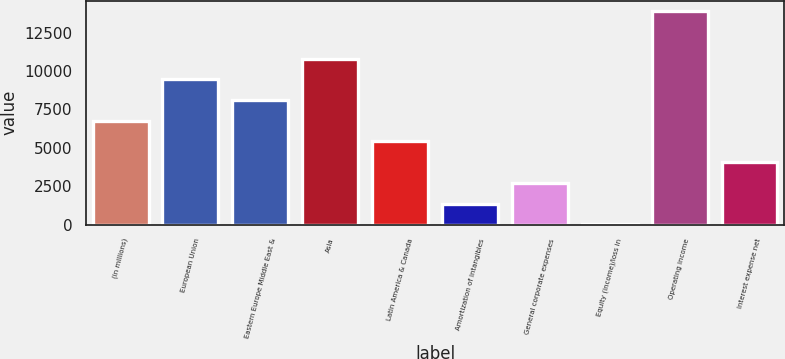Convert chart. <chart><loc_0><loc_0><loc_500><loc_500><bar_chart><fcel>(in millions)<fcel>European Union<fcel>Eastern Europe Middle East &<fcel>Asia<fcel>Latin America & Canada<fcel>Amortization of intangibles<fcel>General corporate expenses<fcel>Equity (income)/loss in<fcel>Operating income<fcel>Interest expense net<nl><fcel>6768.5<fcel>9467.1<fcel>8117.8<fcel>10816.4<fcel>5419.2<fcel>1371.3<fcel>2720.6<fcel>22<fcel>13891.3<fcel>4069.9<nl></chart> 